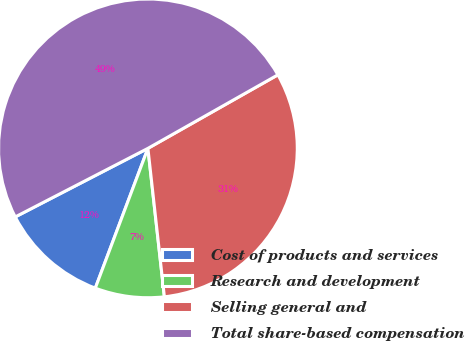Convert chart to OTSL. <chart><loc_0><loc_0><loc_500><loc_500><pie_chart><fcel>Cost of products and services<fcel>Research and development<fcel>Selling general and<fcel>Total share-based compensation<nl><fcel>11.68%<fcel>7.49%<fcel>31.44%<fcel>49.4%<nl></chart> 